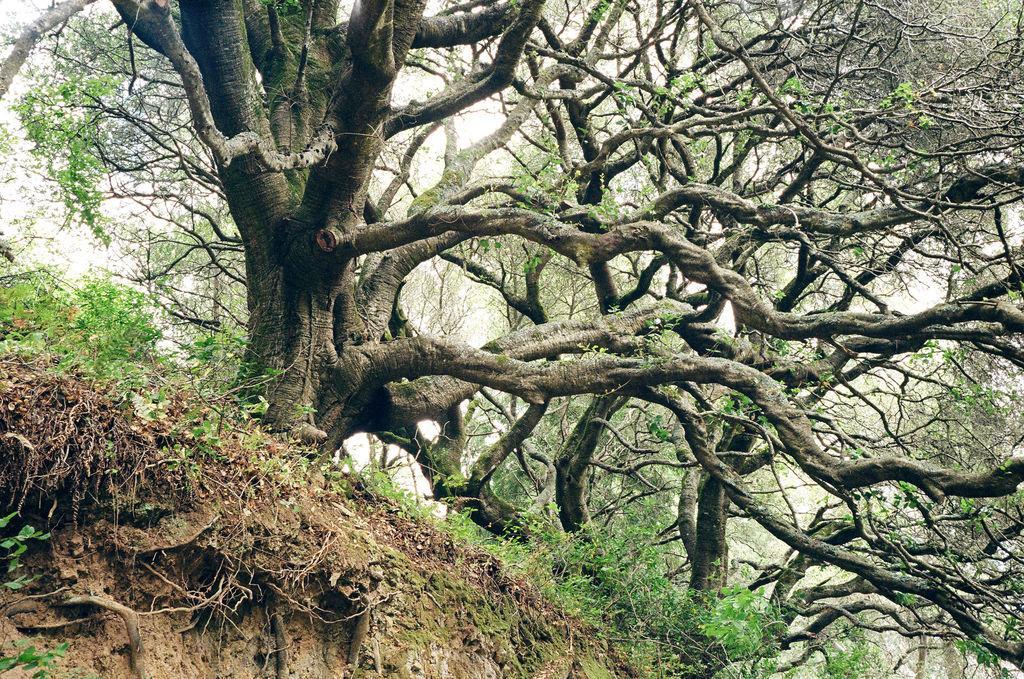In one or two sentences, can you explain what this image depicts? These are the very big trees, this is the soil on the left side of an image. 